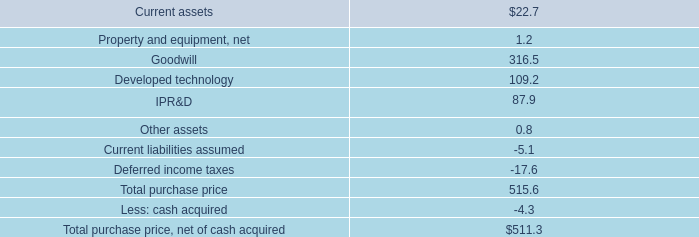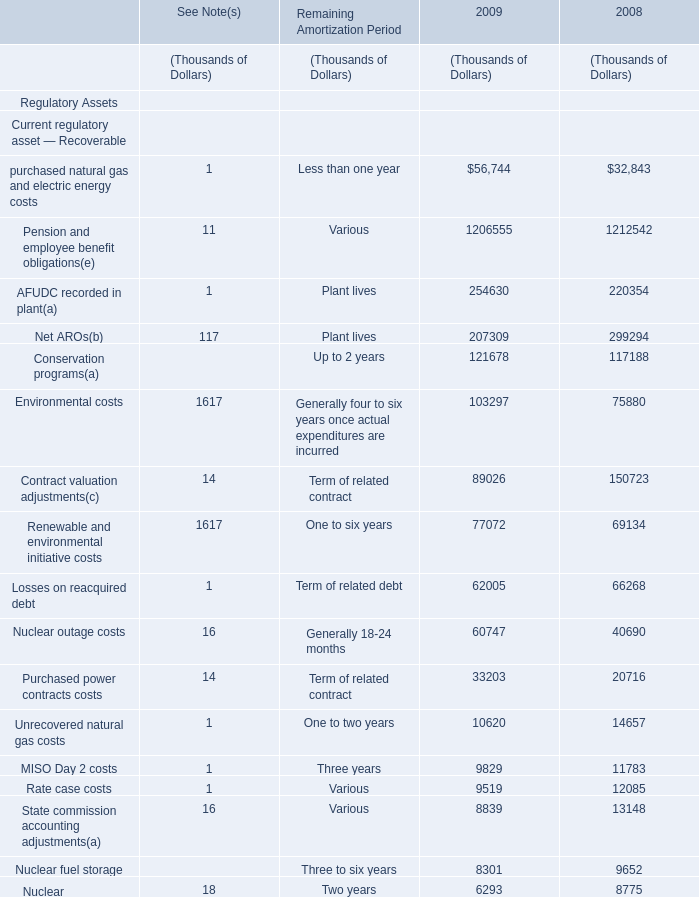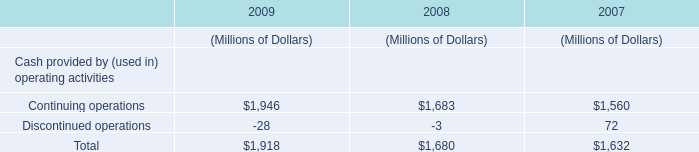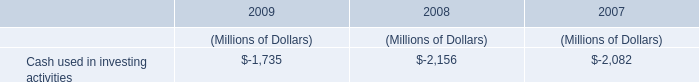What was the value of the Total noncurrent regulatory liabilities in the year where the value of Total noncurrent regulatory assets is smaller? (in thousand) 
Answer: 1222833. 